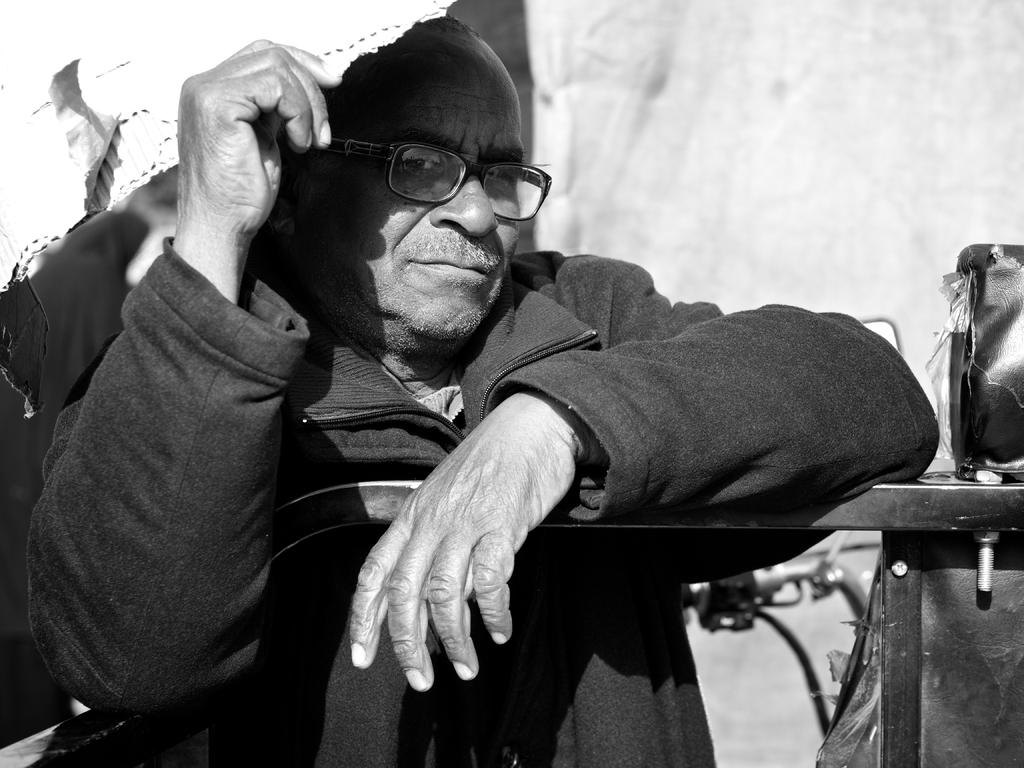Who is present in the image? There is a man in the image. What is the man doing in the image? The man is standing in the image. What is the man wearing in the image? The man is wearing a coat and spectacles in the image. What is the man holding in the image? The man is holding a card in his hand in the image. What else can be seen in the image? There is a vehicle visible in the image. What type of wire is being used to create the flame in the image? There is no wire or flame present in the image. What question is the man asking in the image? The image does not show the man asking a question. 